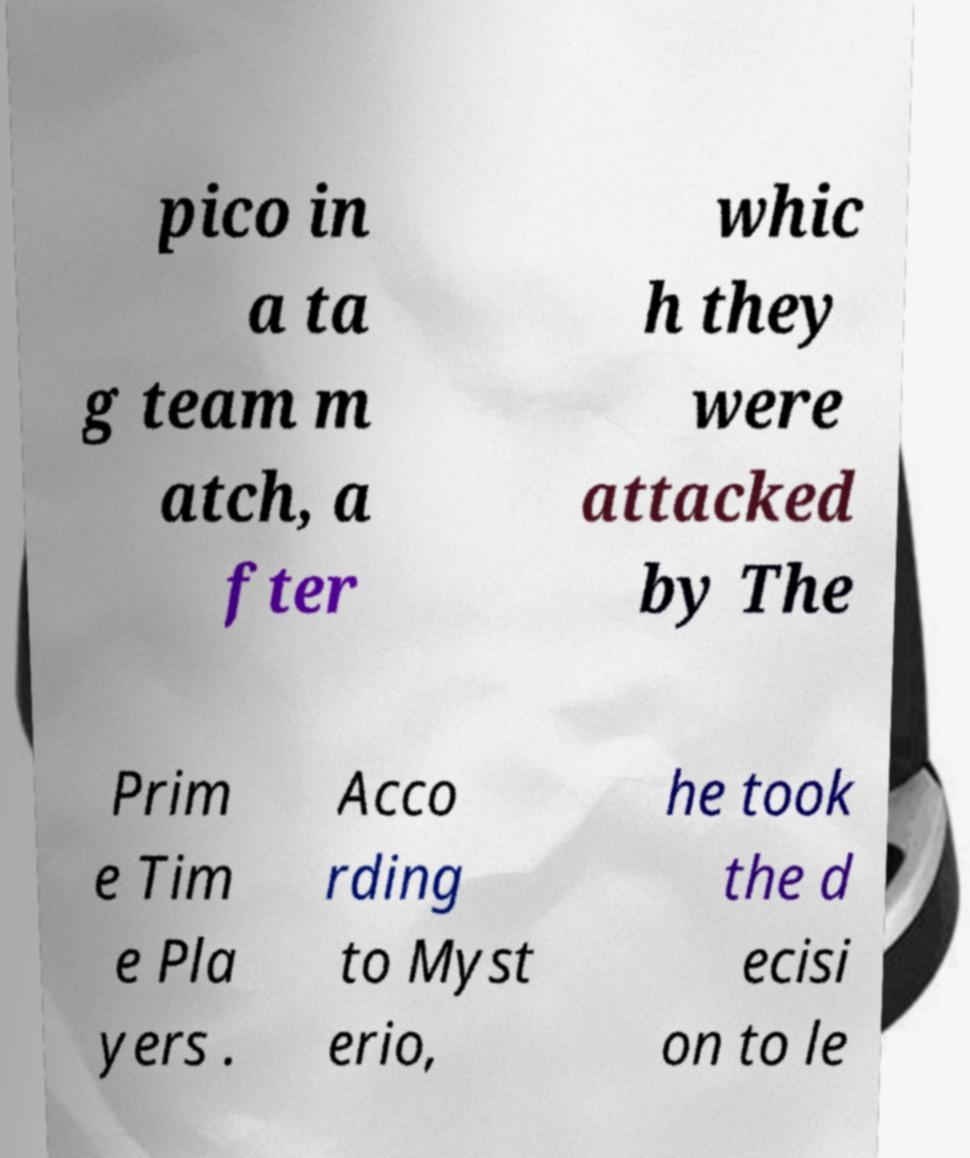I need the written content from this picture converted into text. Can you do that? pico in a ta g team m atch, a fter whic h they were attacked by The Prim e Tim e Pla yers . Acco rding to Myst erio, he took the d ecisi on to le 